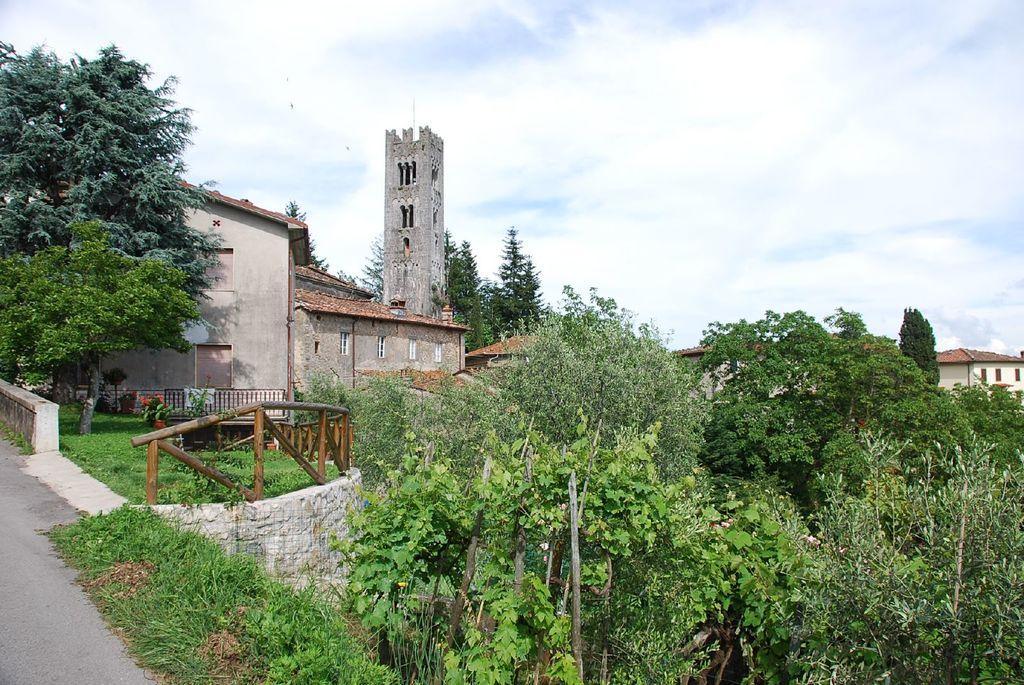Describe this image in one or two sentences. In this picture we can see the buildings and monument. On the left we can see the wooden fencing, plants and the road. At the bottom we can see the leaves, plants and trees. At the top we can see the sky and clouds. 